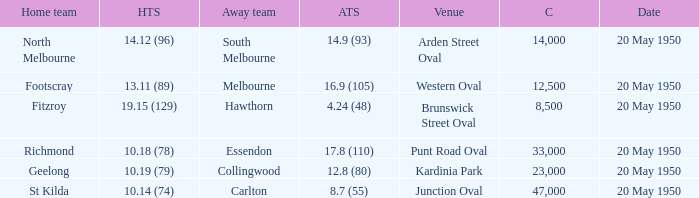What was the largest crowd to view a game where the away team scored 17.8 (110)? 33000.0. 